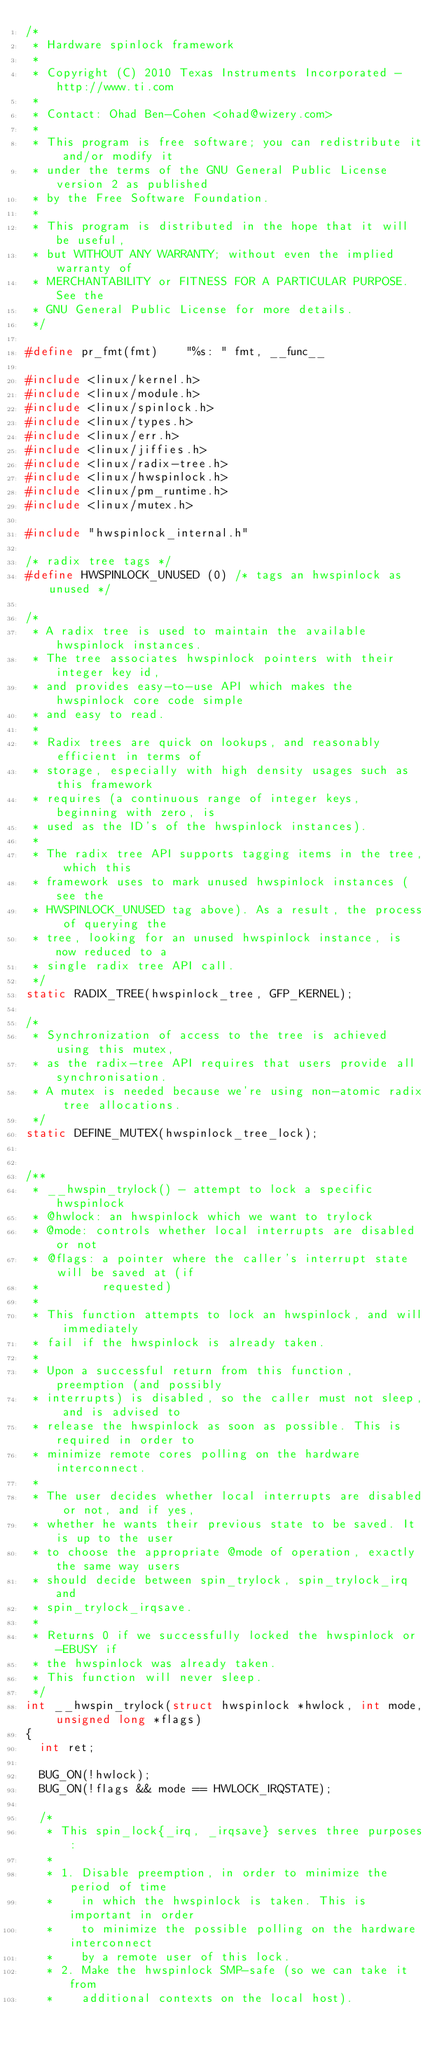Convert code to text. <code><loc_0><loc_0><loc_500><loc_500><_C_>/*
 * Hardware spinlock framework
 *
 * Copyright (C) 2010 Texas Instruments Incorporated - http://www.ti.com
 *
 * Contact: Ohad Ben-Cohen <ohad@wizery.com>
 *
 * This program is free software; you can redistribute it and/or modify it
 * under the terms of the GNU General Public License version 2 as published
 * by the Free Software Foundation.
 *
 * This program is distributed in the hope that it will be useful,
 * but WITHOUT ANY WARRANTY; without even the implied warranty of
 * MERCHANTABILITY or FITNESS FOR A PARTICULAR PURPOSE.  See the
 * GNU General Public License for more details.
 */

#define pr_fmt(fmt)    "%s: " fmt, __func__

#include <linux/kernel.h>
#include <linux/module.h>
#include <linux/spinlock.h>
#include <linux/types.h>
#include <linux/err.h>
#include <linux/jiffies.h>
#include <linux/radix-tree.h>
#include <linux/hwspinlock.h>
#include <linux/pm_runtime.h>
#include <linux/mutex.h>

#include "hwspinlock_internal.h"

/* radix tree tags */
#define HWSPINLOCK_UNUSED	(0) /* tags an hwspinlock as unused */

/*
 * A radix tree is used to maintain the available hwspinlock instances.
 * The tree associates hwspinlock pointers with their integer key id,
 * and provides easy-to-use API which makes the hwspinlock core code simple
 * and easy to read.
 *
 * Radix trees are quick on lookups, and reasonably efficient in terms of
 * storage, especially with high density usages such as this framework
 * requires (a continuous range of integer keys, beginning with zero, is
 * used as the ID's of the hwspinlock instances).
 *
 * The radix tree API supports tagging items in the tree, which this
 * framework uses to mark unused hwspinlock instances (see the
 * HWSPINLOCK_UNUSED tag above). As a result, the process of querying the
 * tree, looking for an unused hwspinlock instance, is now reduced to a
 * single radix tree API call.
 */
static RADIX_TREE(hwspinlock_tree, GFP_KERNEL);

/*
 * Synchronization of access to the tree is achieved using this mutex,
 * as the radix-tree API requires that users provide all synchronisation.
 * A mutex is needed because we're using non-atomic radix tree allocations.
 */
static DEFINE_MUTEX(hwspinlock_tree_lock);


/**
 * __hwspin_trylock() - attempt to lock a specific hwspinlock
 * @hwlock: an hwspinlock which we want to trylock
 * @mode: controls whether local interrupts are disabled or not
 * @flags: a pointer where the caller's interrupt state will be saved at (if
 *         requested)
 *
 * This function attempts to lock an hwspinlock, and will immediately
 * fail if the hwspinlock is already taken.
 *
 * Upon a successful return from this function, preemption (and possibly
 * interrupts) is disabled, so the caller must not sleep, and is advised to
 * release the hwspinlock as soon as possible. This is required in order to
 * minimize remote cores polling on the hardware interconnect.
 *
 * The user decides whether local interrupts are disabled or not, and if yes,
 * whether he wants their previous state to be saved. It is up to the user
 * to choose the appropriate @mode of operation, exactly the same way users
 * should decide between spin_trylock, spin_trylock_irq and
 * spin_trylock_irqsave.
 *
 * Returns 0 if we successfully locked the hwspinlock or -EBUSY if
 * the hwspinlock was already taken.
 * This function will never sleep.
 */
int __hwspin_trylock(struct hwspinlock *hwlock, int mode, unsigned long *flags)
{
	int ret;

	BUG_ON(!hwlock);
	BUG_ON(!flags && mode == HWLOCK_IRQSTATE);

	/*
	 * This spin_lock{_irq, _irqsave} serves three purposes:
	 *
	 * 1. Disable preemption, in order to minimize the period of time
	 *    in which the hwspinlock is taken. This is important in order
	 *    to minimize the possible polling on the hardware interconnect
	 *    by a remote user of this lock.
	 * 2. Make the hwspinlock SMP-safe (so we can take it from
	 *    additional contexts on the local host).</code> 